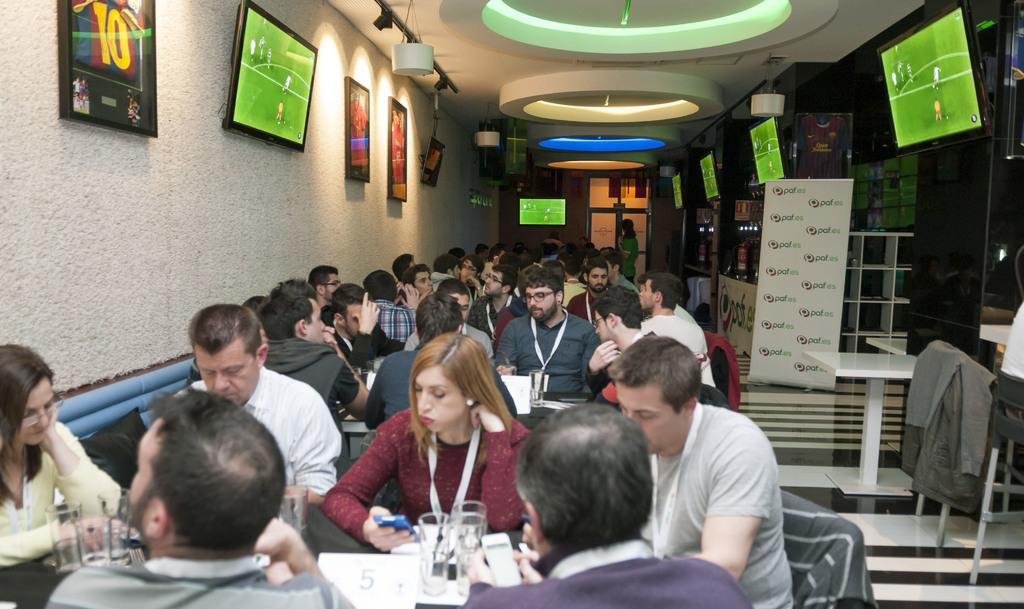What are the people in the image doing? The people in the image are sitting in chairs. What is in front of the people? There is a table in front of the people. What can be seen on the table? There are objects on the table. What is located on either side of the people? There are televisions on either side of the people. What type of bushes can be seen growing around the tank in the image? There is no tank or bushes present in the image. 